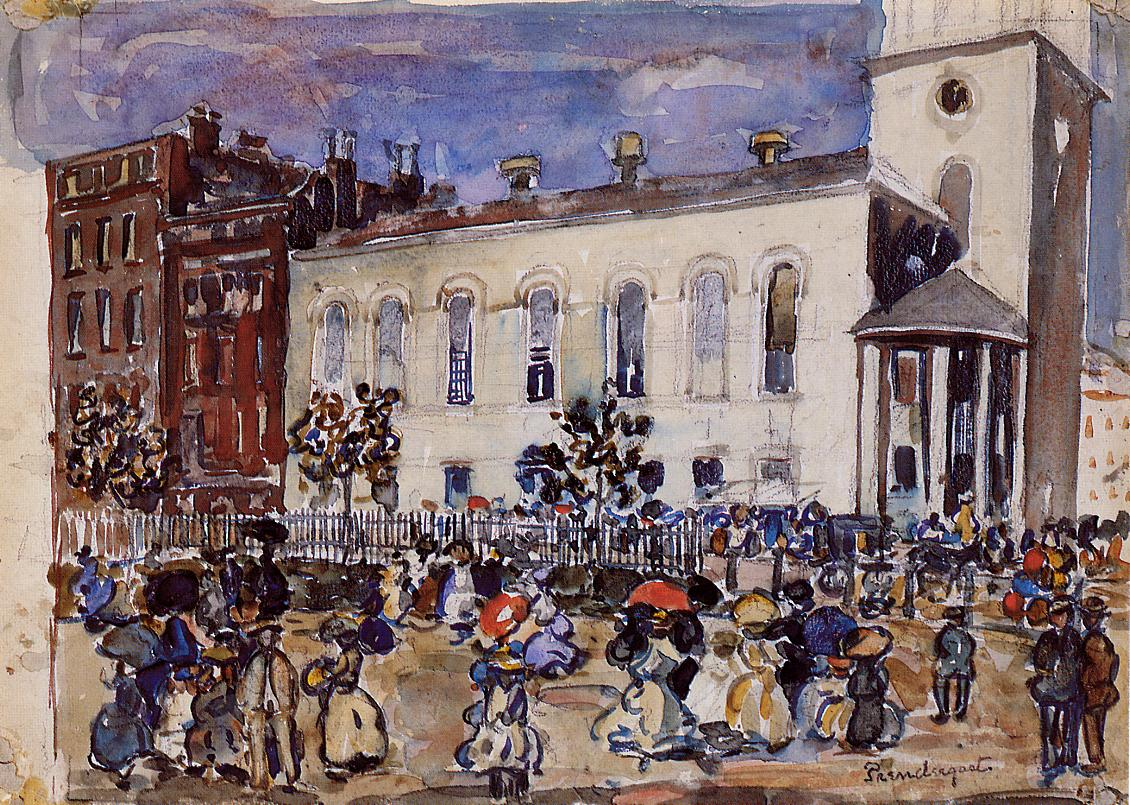Can you elaborate on the elements of the picture provided? The image is an evocative portrayal of a vibrant street scene, likely set in the early 20th century and rendered in an impressionist style. The loose, flowing brushwork captures the movement and bustling energy of the people depicted. Figures in period clothing engage in various activities such as walking, conversing, and carrying items, adding layers of narrative to the scene. The color palette predominantly consists of earthy tones, with blues and greens providing contrast and depth. A prominent white building with a distinctive tall tower dominates the background, its architectural features painted with a similar fluid technique. The overall composition delivers a dynamic and immersive slice of historical urban life, rich in details and harmonious in its use of color and form. 